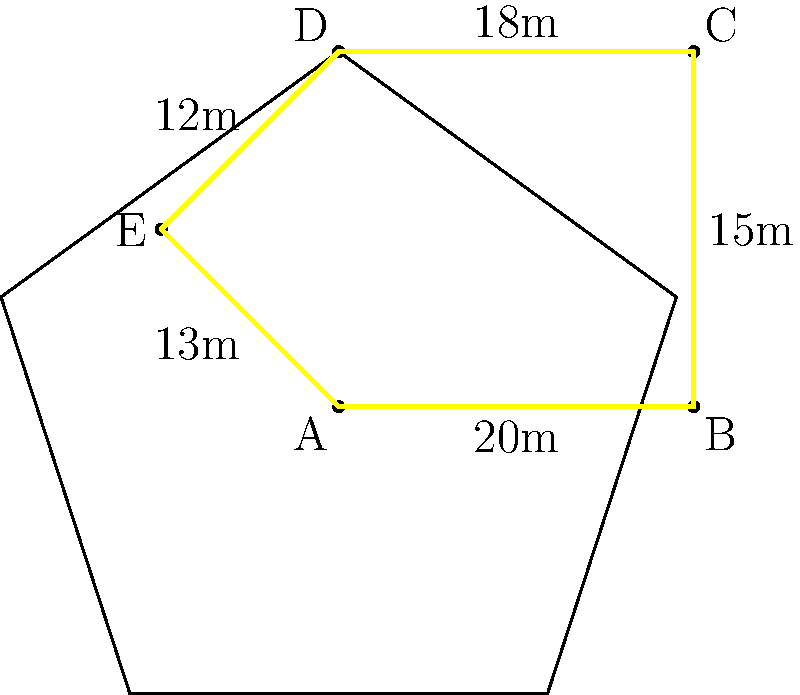At a recent crime scene, you've outlined the area with police tape as shown in the diagram. The crime scene forms an irregular pentagon with side lengths of 20m, 15m, 18m, 12m, and 13m. Calculate the total area of the crime scene to determine the amount of investigative resources needed. To calculate the area of this irregular pentagon, we can divide it into simpler shapes:
1. A rectangle (ABCD)
2. A right triangle (ADE)

Step 1: Calculate the area of the rectangle ABCD
- Length = 20m, Width = 15m
- Area of rectangle = $20m \times 15m = 300m^2$

Step 2: Calculate the area of the right triangle ADE
- We can use Heron's formula to find the area of this triangle
- Heron's formula: $A = \sqrt{s(s-a)(s-b)(s-c)}$
  where $s = \frac{a+b+c}{2}$ (semi-perimeter)
  and $a$, $b$, and $c$ are the side lengths

- $a = 12m$, $b = 13m$, $c = 20m$
- $s = \frac{12 + 13 + 20}{2} = 22.5m$

- Area of triangle = $\sqrt{22.5(22.5-12)(22.5-13)(22.5-20)}$
                   = $\sqrt{22.5 \times 10.5 \times 9.5 \times 2.5}$
                   = $\sqrt{5578.125}$
                   = $74.69m^2$ (rounded to 2 decimal places)

Step 3: Calculate the total area
Total Area = Area of rectangle + Area of triangle
           = $300m^2 + 74.69m^2$
           = $374.69m^2$

Therefore, the total area of the crime scene is approximately 374.69 square meters.
Answer: $374.69m^2$ 